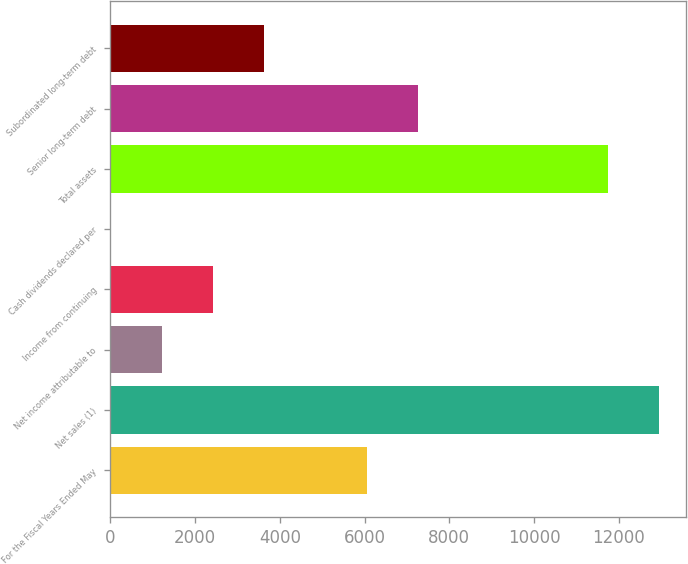Convert chart. <chart><loc_0><loc_0><loc_500><loc_500><bar_chart><fcel>For the Fiscal Years Ended May<fcel>Net sales (1)<fcel>Net income attributable to<fcel>Income from continuing<fcel>Cash dividends declared per<fcel>Total assets<fcel>Senior long-term debt<fcel>Subordinated long-term debt<nl><fcel>6048.79<fcel>12947.6<fcel>1210.39<fcel>2419.99<fcel>0.79<fcel>11738<fcel>7258.39<fcel>3629.59<nl></chart> 